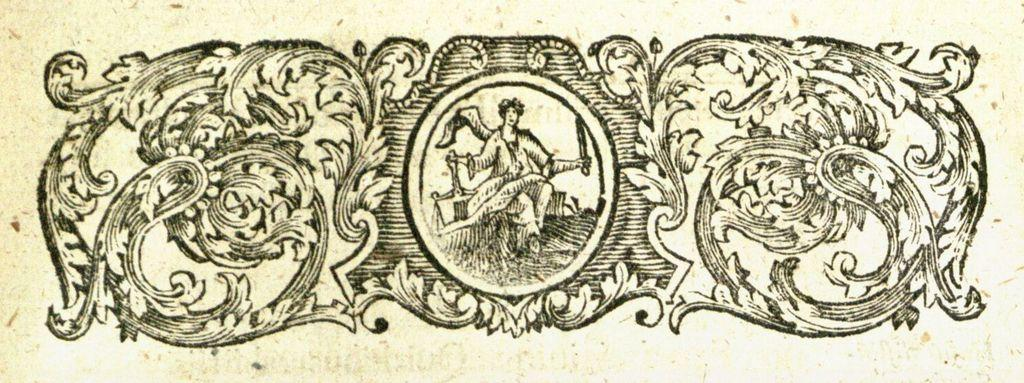What is the main subject of the sketch in the image? There is a sketch of a person in the center of the image. What is the person in the sketch doing? The person is holding objects in the sketch. What is the position of the person in the sketch? The person appears to be standing in the sketch. Are there any other sketches in the image besides the person? Yes, there are sketches of other objects in the image. How many yaks are present in the image? There are no yaks present in the image; it features a sketch of a person and other objects. What type of birds can be seen flying in the image? There are no birds visible in the image; it contains sketches of a person and other objects. 